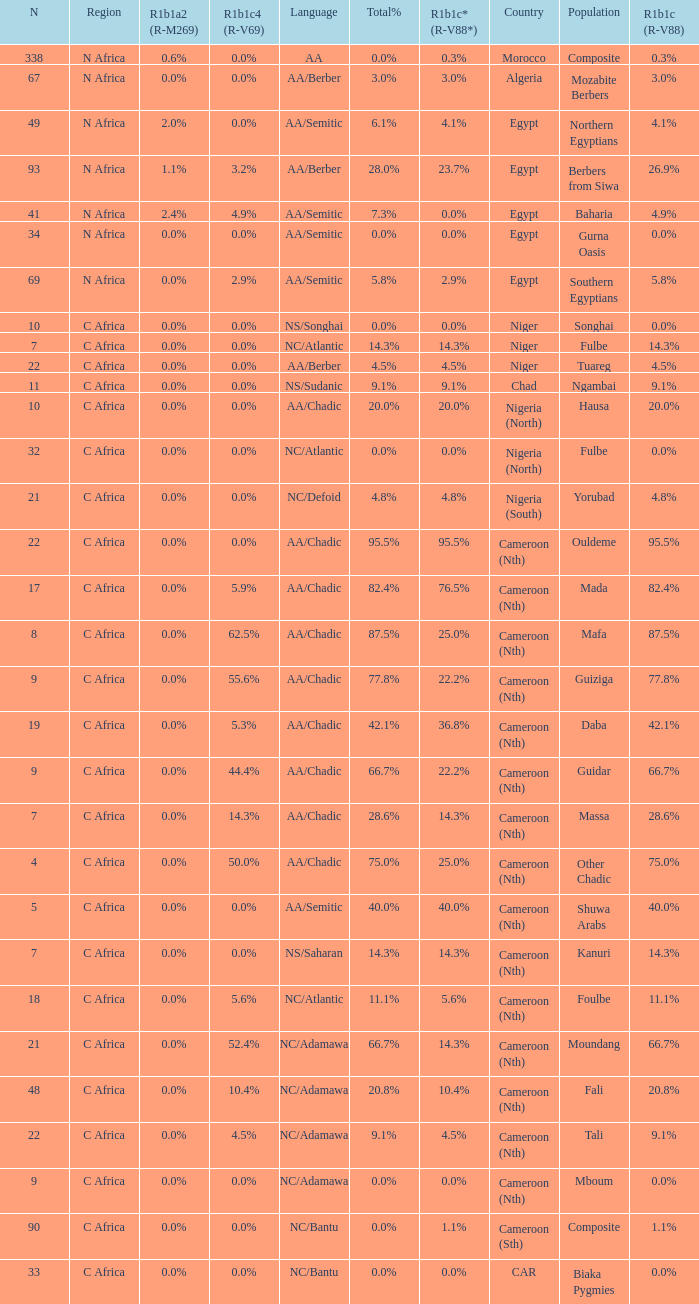What percentage is listed in column r1b1c (r-v88) for the 4.5% total percentage? 4.5%. 